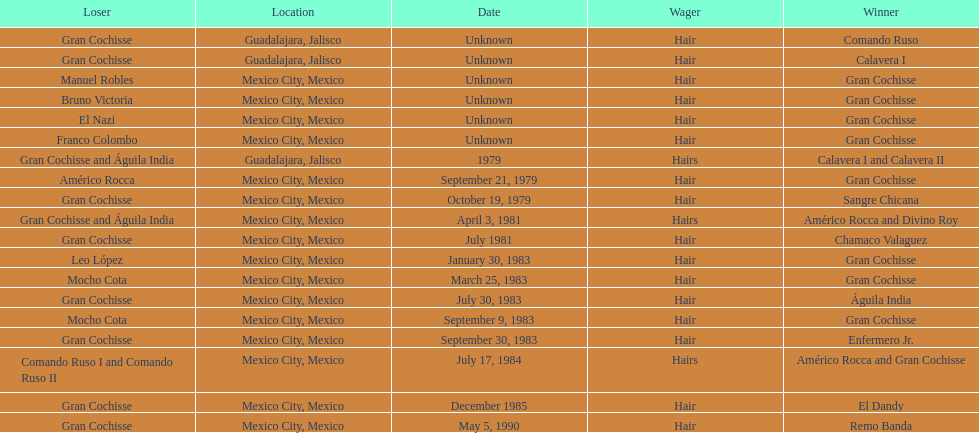How many times has gran cochisse been a winner? 9. 